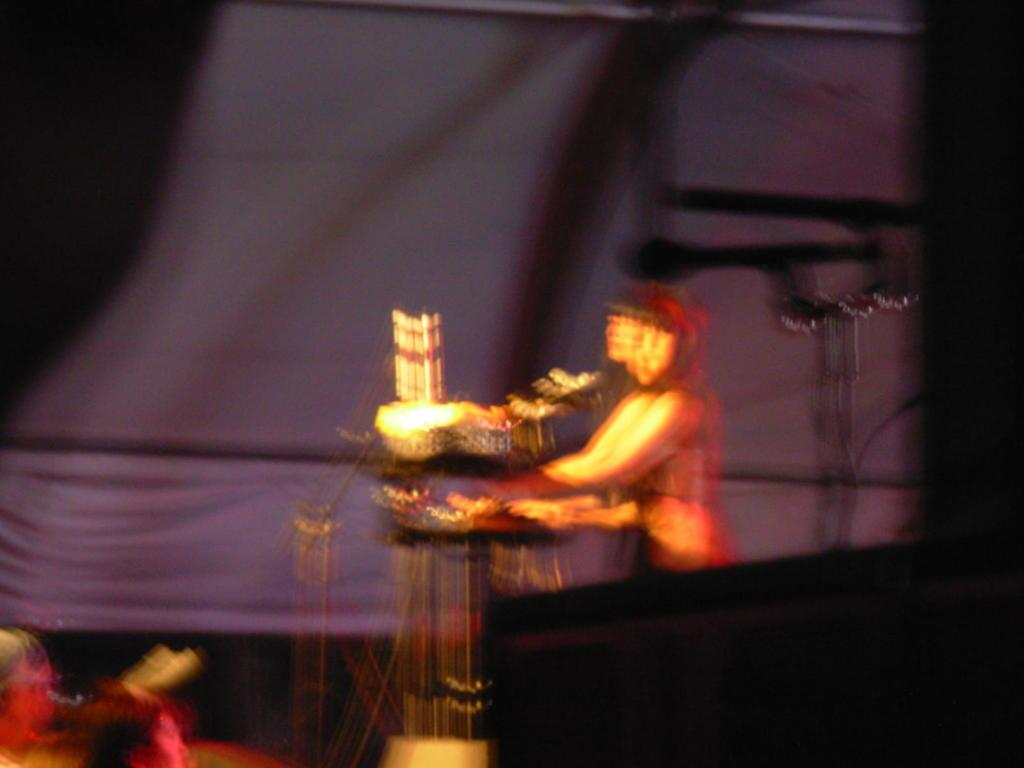What can be seen in the image that is not in focus? There is a blurred person in the image. What is located in front of the person in the image? There are musical instruments in front of the person. What can be seen in the background of the image? There is a curtain in the background of the image. What type of bells can be heard ringing in the image? There are no bells present in the image, and therefore no sound can be heard. 